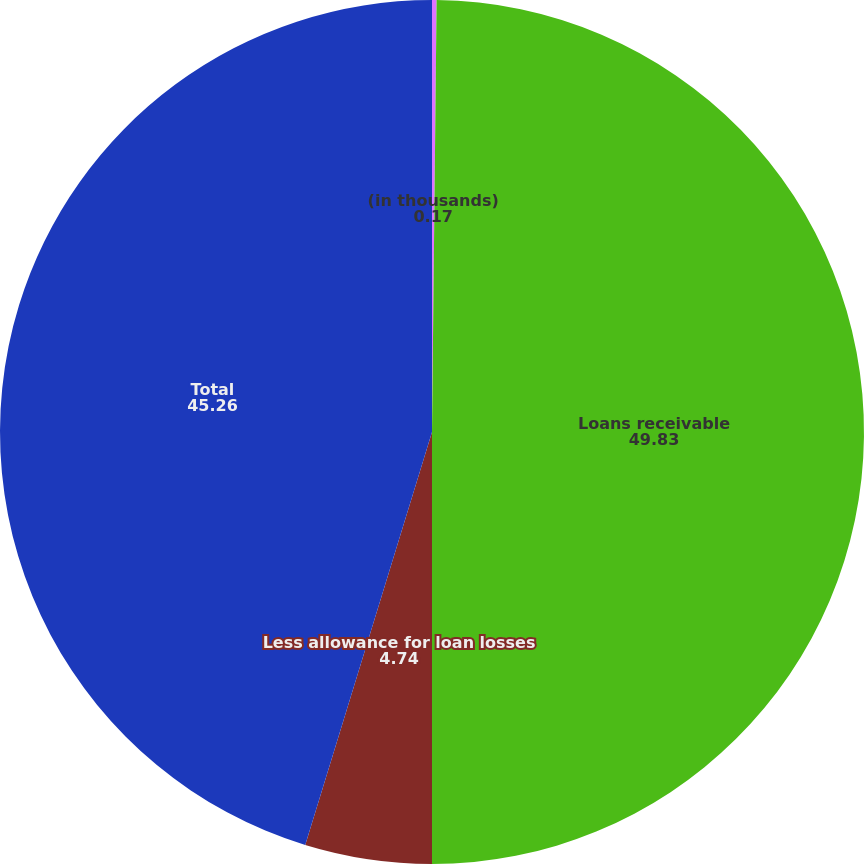Convert chart. <chart><loc_0><loc_0><loc_500><loc_500><pie_chart><fcel>(in thousands)<fcel>Loans receivable<fcel>Less allowance for loan losses<fcel>Total<nl><fcel>0.17%<fcel>49.83%<fcel>4.74%<fcel>45.26%<nl></chart> 